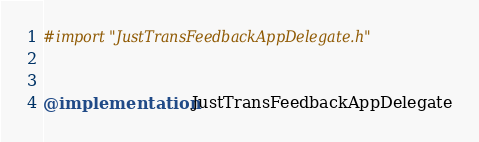<code> <loc_0><loc_0><loc_500><loc_500><_ObjectiveC_>#import "JustTransFeedbackAppDelegate.h"


@implementation JustTransFeedbackAppDelegate
</code> 